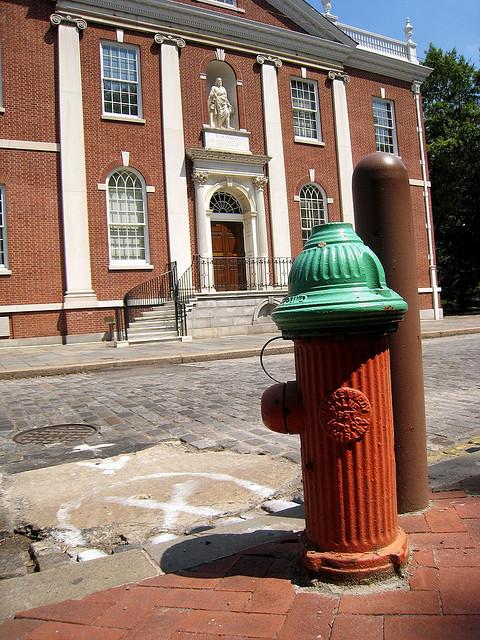Is the entrance of the house impressive?
Give a very brief answer. Yes. What color is the fire hydrant?
Keep it brief. Red and green. Is this an intersection?
Give a very brief answer. No. What is behind the fire hydrant?
Give a very brief answer. Pole. What color is on the top of the hydrant?
Give a very brief answer. Green. 